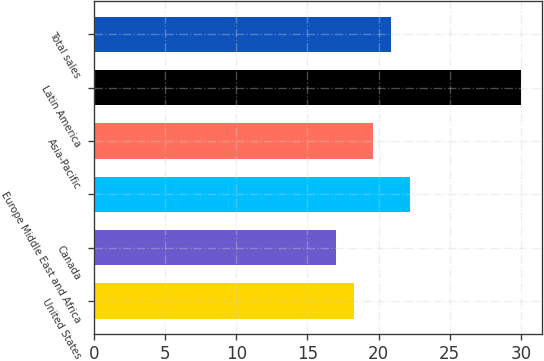Convert chart to OTSL. <chart><loc_0><loc_0><loc_500><loc_500><bar_chart><fcel>United States<fcel>Canada<fcel>Europe Middle East and Africa<fcel>Asia-Pacific<fcel>Latin America<fcel>Total sales<nl><fcel>18.3<fcel>17<fcel>22.2<fcel>19.6<fcel>30<fcel>20.9<nl></chart> 